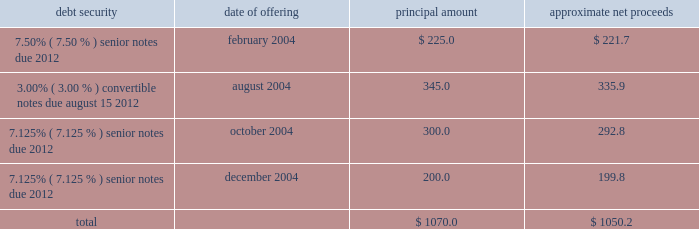Proceeds from the sale of equity securities .
From time to time , we raise funds through public offerings of our equity securities .
In addition , we receive proceeds from sales of our equity securities pursuant to our stock option and stock purchase plans .
For the year ended december 31 , 2004 , we received approximately $ 40.6 million in proceeds from sales of shares of our class a common stock and the common stock of atc mexico pursuant to our stock option and stock purchase plans .
Financing activities during the year ended december 31 , 2004 , we took several actions to increase our financial flexibility and reduce our interest costs .
New credit facility .
In may 2004 , we refinanced our previous credit facility with a new $ 1.1 billion senior secured credit facility .
At closing , we received $ 685.5 million of net proceeds from the borrowings under the new facility , after deducting related expenses and fees , approximately $ 670.0 million of which we used to repay principal and interest under the previous credit facility .
We used the remaining net proceeds of $ 15.5 million for general corporate purposes , including the repurchase of other outstanding debt securities .
The new credit facility consists of the following : 2022 $ 400.0 million in undrawn revolving loan commitments , against which approximately $ 19.3 million of undrawn letters of credit were outstanding at december 31 , 2004 , maturing on february 28 , 2011 ; 2022 a $ 300.0 million term loan a , which is fully drawn , maturing on february 28 , 2011 ; and 2022 a $ 398.0 million term loan b , which is fully drawn , maturing on august 31 , 2011 .
The new credit facility extends the previous credit facility maturity dates from 2007 to 2011 for a majority of the borrowings outstanding , subject to earlier maturity upon the occurrence of certain events described below , and allows us to use credit facility borrowings and internally generated funds to repurchase other indebtedness without additional lender approval .
The new credit facility is guaranteed by us and is secured by a pledge of substantially all of our assets .
The maturity date for term loan a and any outstanding revolving loans will be accelerated to august 15 , 2008 , and the maturity date for term loan b will be accelerated to october 31 , 2008 , if ( 1 ) on or prior to august 1 , 2008 , our 93 20448% ( 20448 % ) senior notes have not been ( a ) refinanced with parent company indebtedness having a maturity date of february 28 , 2012 or later or with loans under the new credit facility , or ( b ) repaid , prepaid , redeemed , repurchased or otherwise retired , and ( 2 ) our consolidated leverage ratio ( total parent company debt to annualized operating cash flow ) at june 30 , 2008 is greater than 4.50 to 1.00 .
If this were to occur , the payments due in 2008 for term loan a and term loan b would be $ 225.0 million and $ 386.0 million , respectively .
Note offerings .
During 2004 , we raised approximately $ 1.1 billion in net proceeds from the sale of debt securities through institutional private placements as follows ( in millions ) : debt security date of offering principal amount approximate net proceeds .
2022 7.50% ( 7.50 % ) senior notes offering .
In february 2004 , we sold $ 225.0 million principal amount of our 7.50% ( 7.50 % ) senior notes due 2012 through an institutional private placement .
The 7.50% ( 7.50 % ) senior notes mature on may 1 , 2012 , and interest is payable semiannually in arrears on may 1 and november 1 of each year. .
What is the annual interest expense related to the 7.50% ( 7.50 % ) senior notes due 2012 , in millions? 
Computations: (225.0 * 7.50%)
Answer: 16.875. 